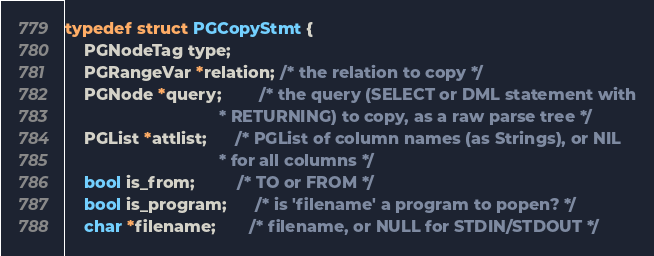<code> <loc_0><loc_0><loc_500><loc_500><_C++_>typedef struct PGCopyStmt {
	PGNodeTag type;
	PGRangeVar *relation; /* the relation to copy */
	PGNode *query;        /* the query (SELECT or DML statement with
								 * RETURNING) to copy, as a raw parse tree */
	PGList *attlist;      /* PGList of column names (as Strings), or NIL
								 * for all columns */
	bool is_from;         /* TO or FROM */
	bool is_program;      /* is 'filename' a program to popen? */
	char *filename;       /* filename, or NULL for STDIN/STDOUT */</code> 